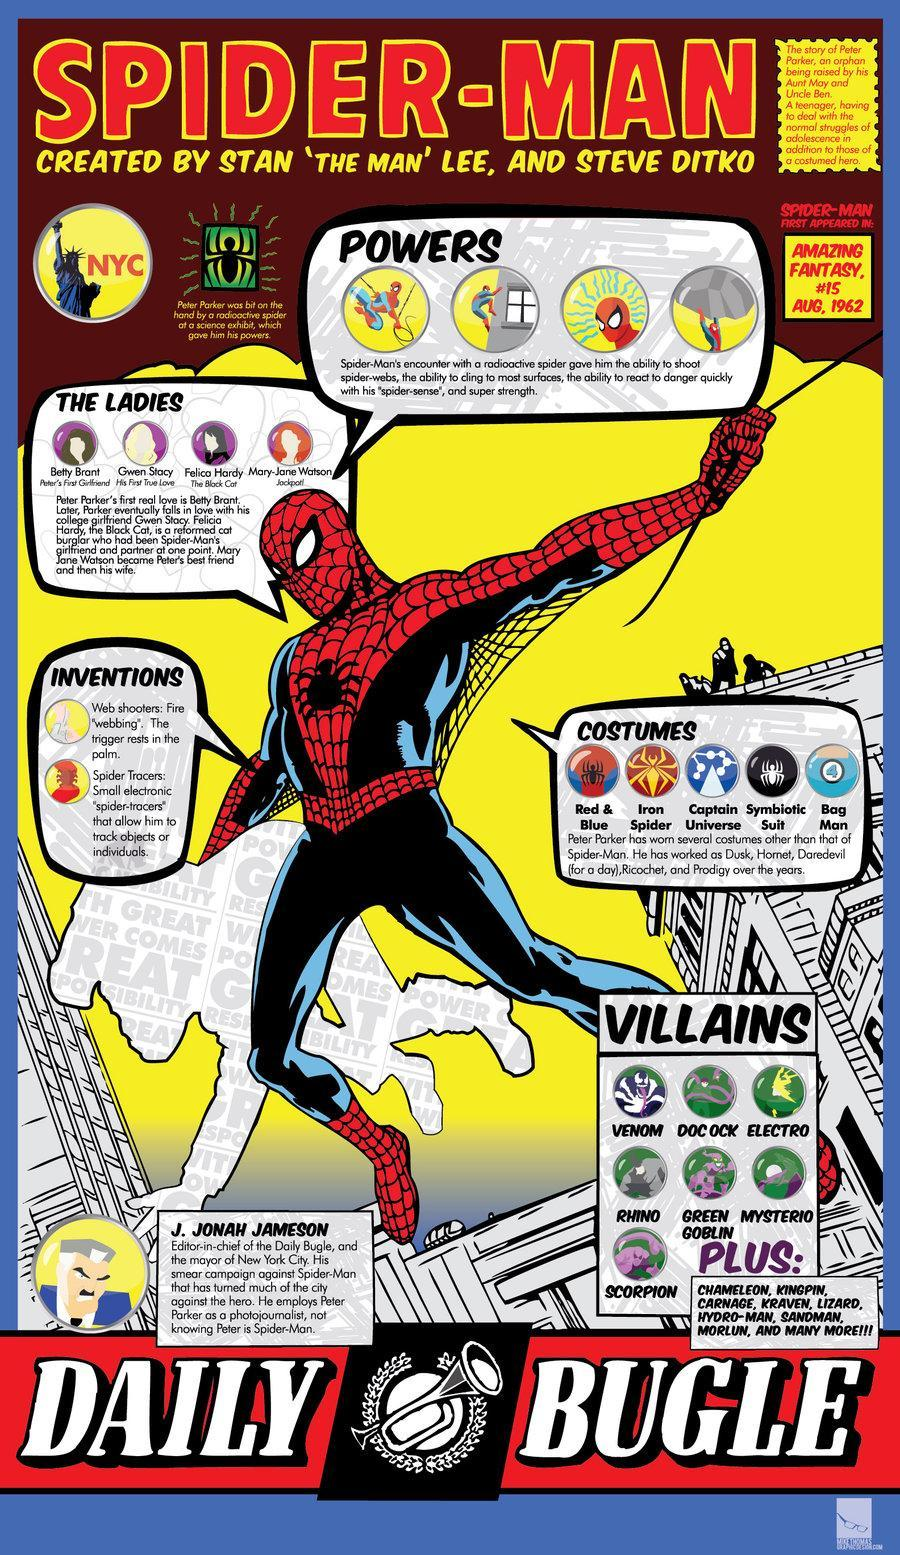What colour is the spider on spider man's suit - red, blue or black?
Answer the question with a short phrase. black How many are illustrated in the box titled villains? 7 When was spider man released? 15 AUG, 1962 